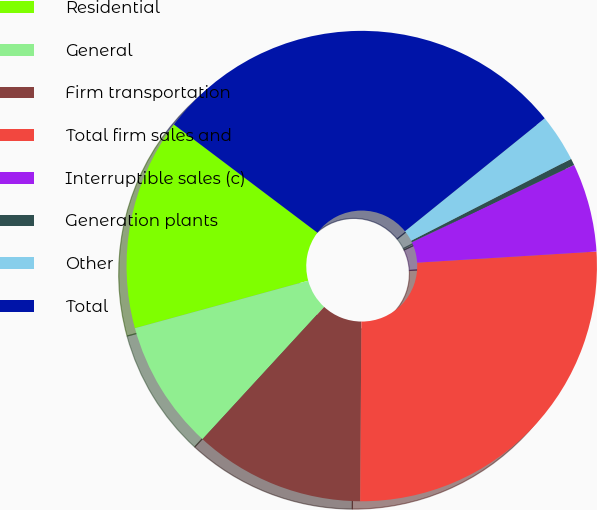<chart> <loc_0><loc_0><loc_500><loc_500><pie_chart><fcel>Residential<fcel>General<fcel>Firm transportation<fcel>Total firm sales and<fcel>Interruptible sales (c)<fcel>Generation plants<fcel>Other<fcel>Total<nl><fcel>14.54%<fcel>8.91%<fcel>11.73%<fcel>26.09%<fcel>6.09%<fcel>0.46%<fcel>3.28%<fcel>28.91%<nl></chart> 